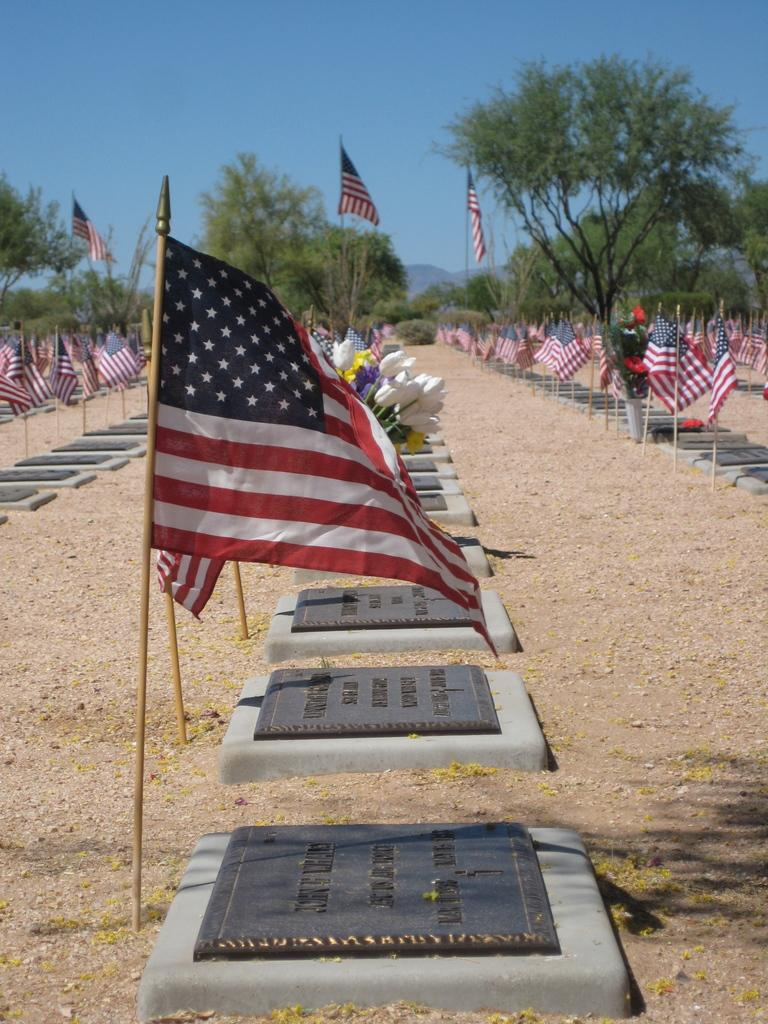What type of structures can be seen in the image? There are grave stones in the image. Are there any other objects or features present in the image? Yes, there are flagpoles with flags in the image. What type of ground is visible in the image? Soil is visible in the image. What can be seen in the background of the image? There are trees in the background of the image. How would you describe the sky in the image? The sky is clear in the image. What type of fang can be seen in the image? There is no fang present in the image. What is the end of the image? The image does not have an end; it is a two-dimensional representation. 